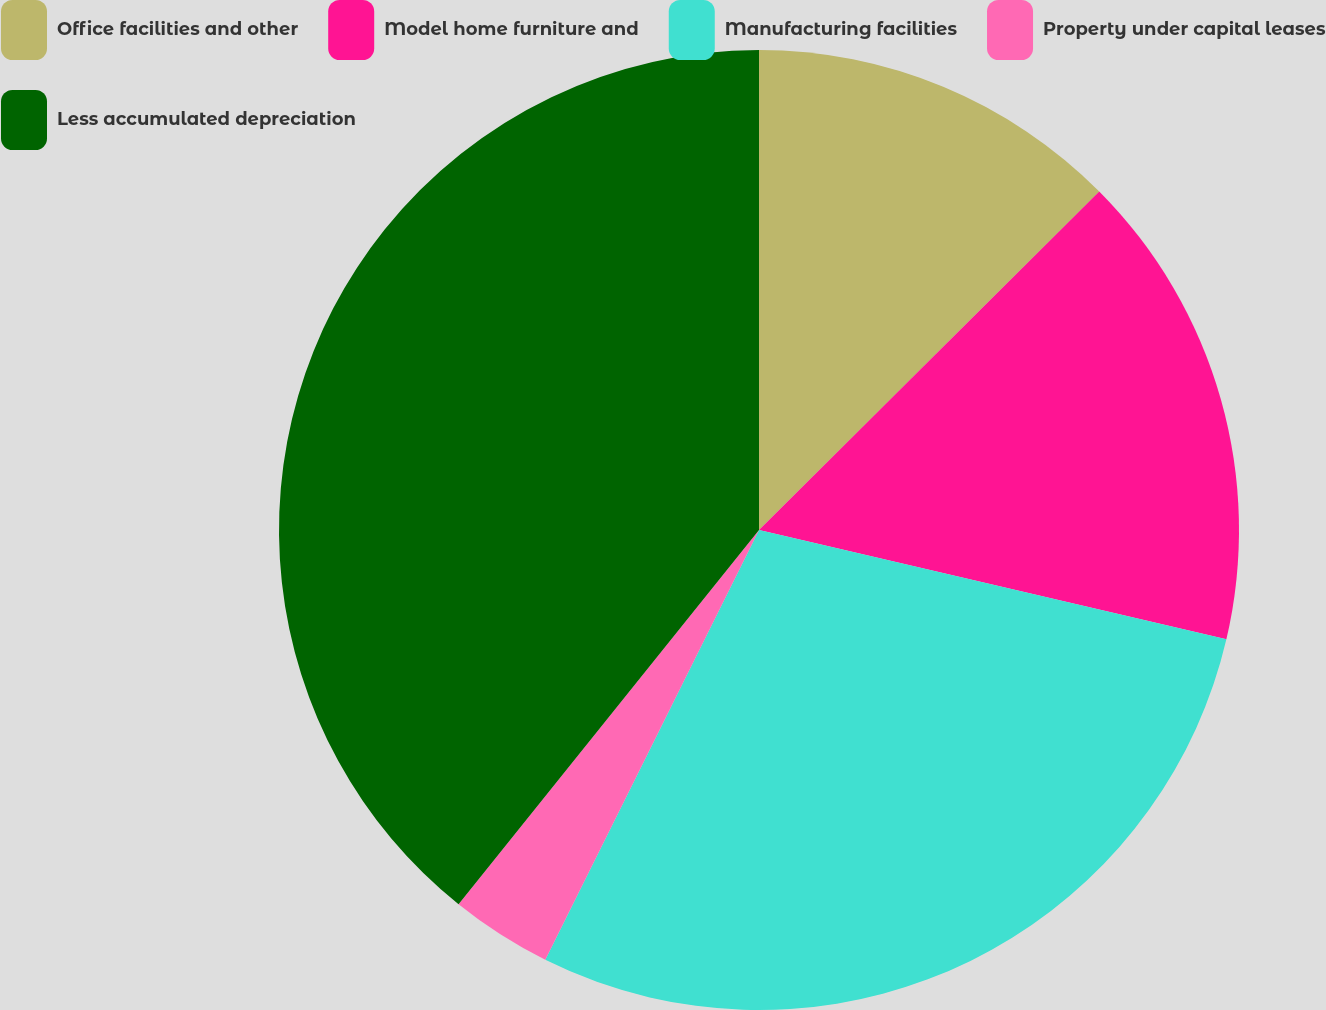Convert chart to OTSL. <chart><loc_0><loc_0><loc_500><loc_500><pie_chart><fcel>Office facilities and other<fcel>Model home furniture and<fcel>Manufacturing facilities<fcel>Property under capital leases<fcel>Less accumulated depreciation<nl><fcel>12.54%<fcel>16.12%<fcel>28.69%<fcel>3.42%<fcel>39.24%<nl></chart> 